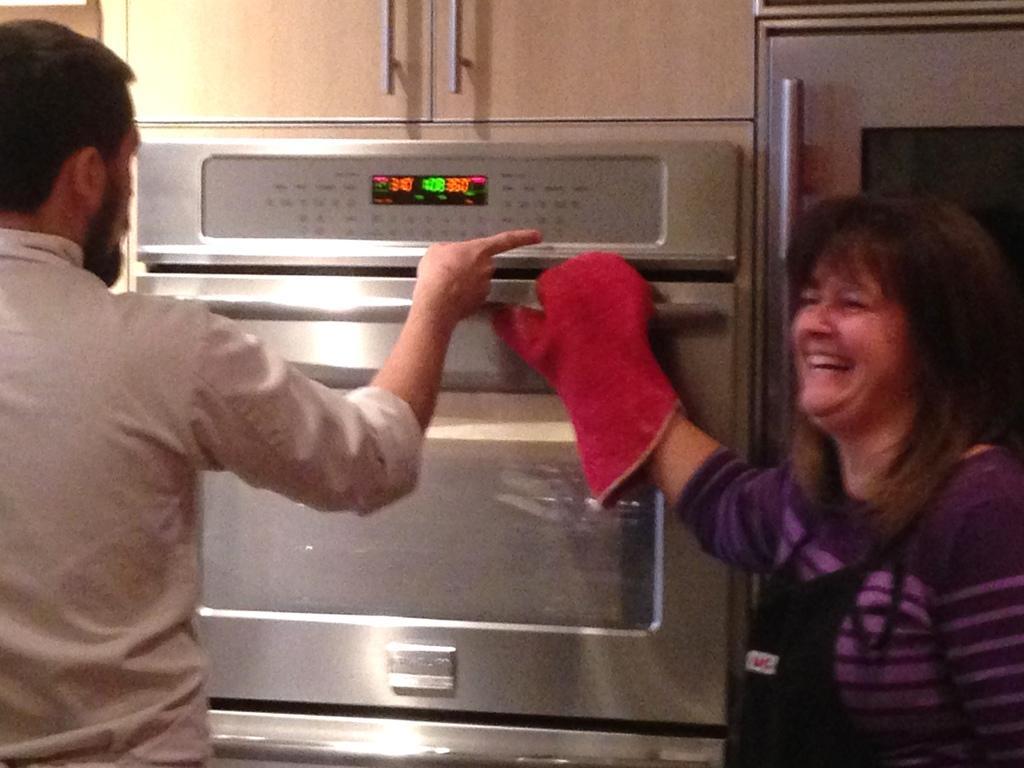How would you summarize this image in a sentence or two? In this picture I can see there is a woman and a man standing here and there is a micro oven and the woman is smiling. 